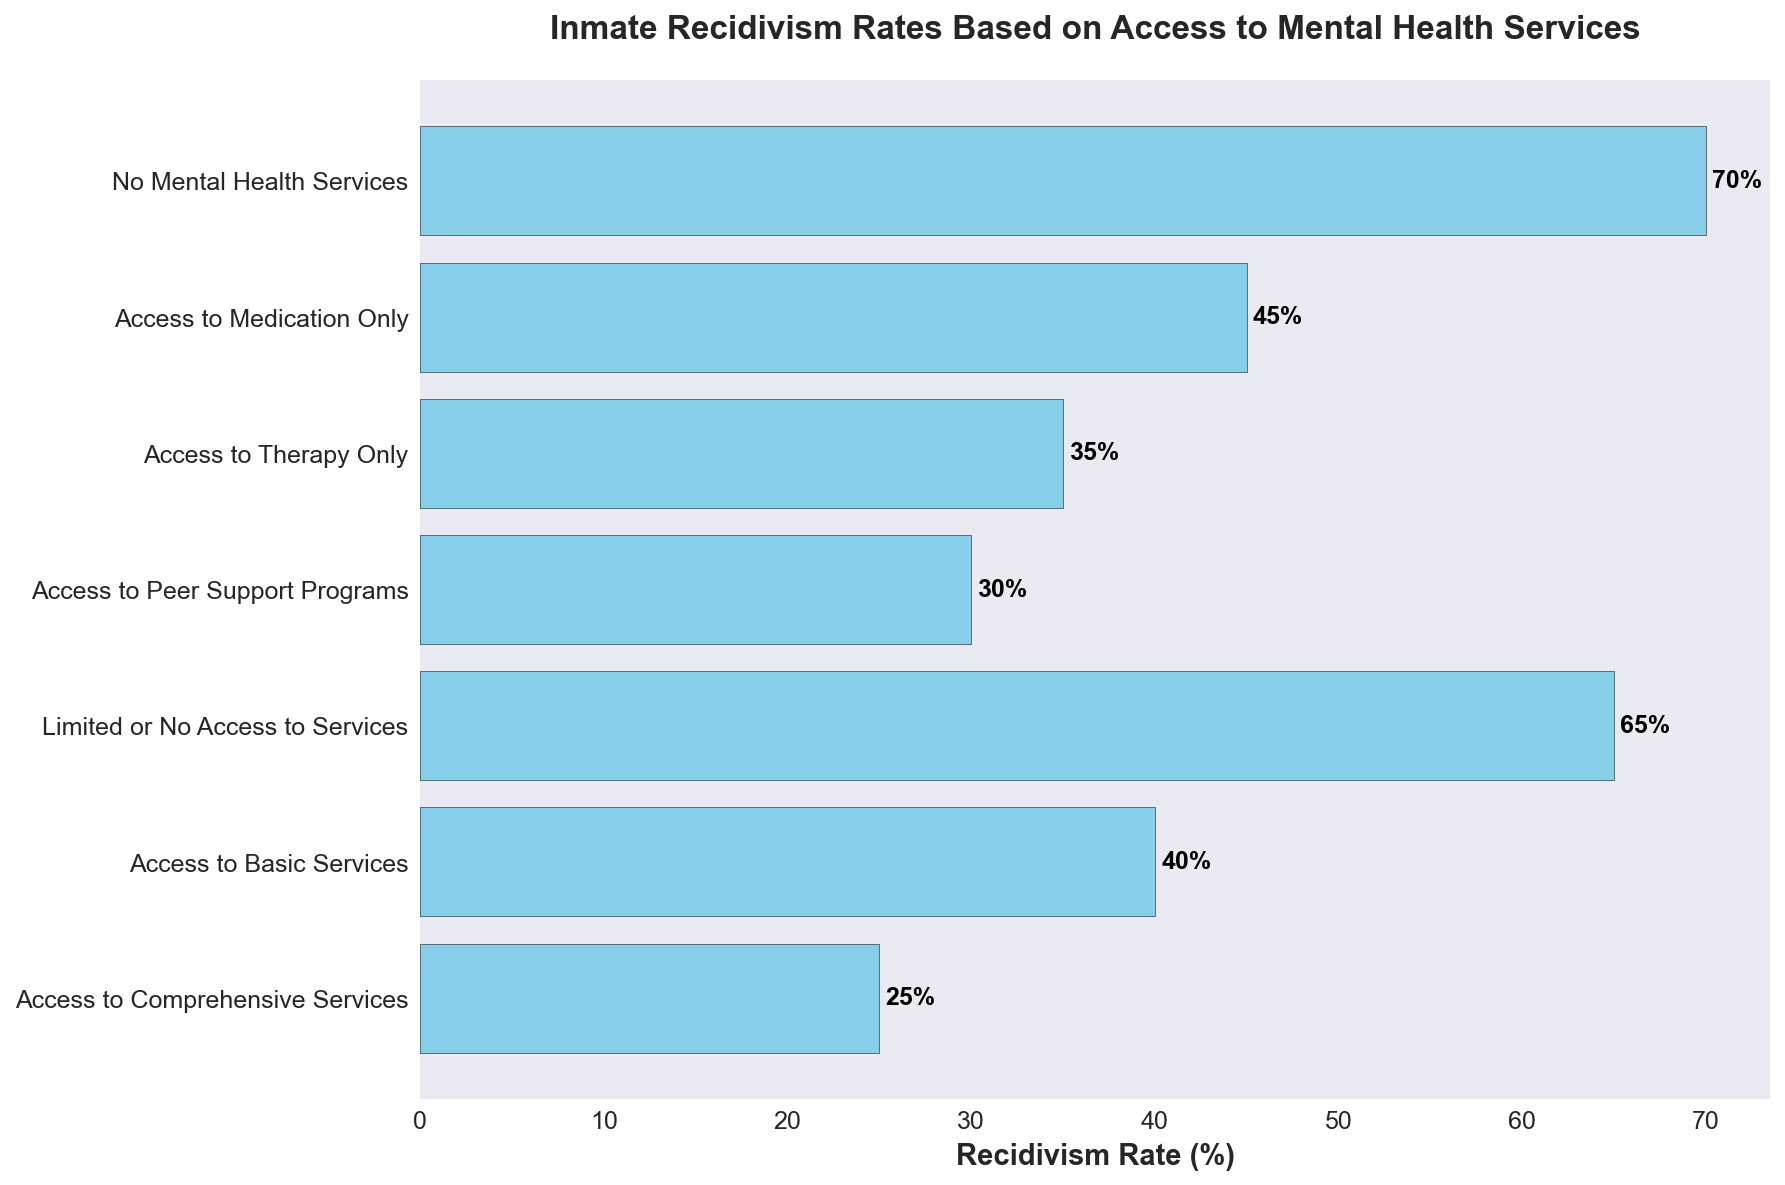What's the recidivism rate for inmates with no mental health services? Looking at the bar labeled "No Mental Health Services," the annotated value indicates the recidivism rate.
Answer: 70% Which category has the lowest recidivism rate, and what is that rate? The shortest bar corresponds to the "Access to Comprehensive Services" category, which has a lower annotated value compared to others.
Answer: Access to Comprehensive Services, 25% How much higher is the recidivism rate for inmates with limited or no access to services compared to those with access to peer support programs? The bar for "Limited or No Access to Services" shows a recidivism rate of 65%, while the bar for "Access to Peer Support Programs" shows 30%. The difference is 65% - 30% = 35%.
Answer: 35% What is the average recidivism rate for inmates with access to any form of mental health service? Considering all categories except "No Mental Health Services," the recidivism rates are 25%, 40%, 30%, 35%, and 45%. The average is calculated as (25 + 40 + 30 + 35 + 45) / 5 = 35%.
Answer: 35% Which is higher, the recidivism rate for "Access to Therapy Only" or "Access to Medication Only," and by how much? The bar for "Access to Therapy Only" shows 35%, while "Access to Medication Only" shows 45%. The difference is 45% - 35% = 10%.
Answer: Access to Medication Only, 10% How does the recidivism rate for "Access to Basic Services" compare to "Access to Comprehensive Services"? The bar for "Access to Basic Services" shows 40%, while "Access to Comprehensive Services" shows 25%. The former is higher.
Answer: Access to Basic Services is higher What is the sum of recidivism rates for categories listed? Summing all the recidivism rates: 25% (Comprehensive) + 40% (Basic) + 65% (Limited/No Access) + 30% (Peer Support) + 35% (Therapy Only) + 45% (Medication Only) + 70% (No Services) = 310%.
Answer: 310% How many categories have recidivism rates of 35% or lower? Bars for "Access to Comprehensive Services" (25%), "Access to Peer Support Programs" (30%), and "Access to Therapy Only" (35%) fit this criterion. Count = 3.
Answer: 3 If an inmate has access to either medication only or peer support programs, what is their combined average recidivism rate? The recidivism rates for "Access to Medication Only" and "Access to Peer Support Programs" are 45% and 30%, respectively. The average is (45 + 30) / 2 = 37.5%.
Answer: 37.5% 